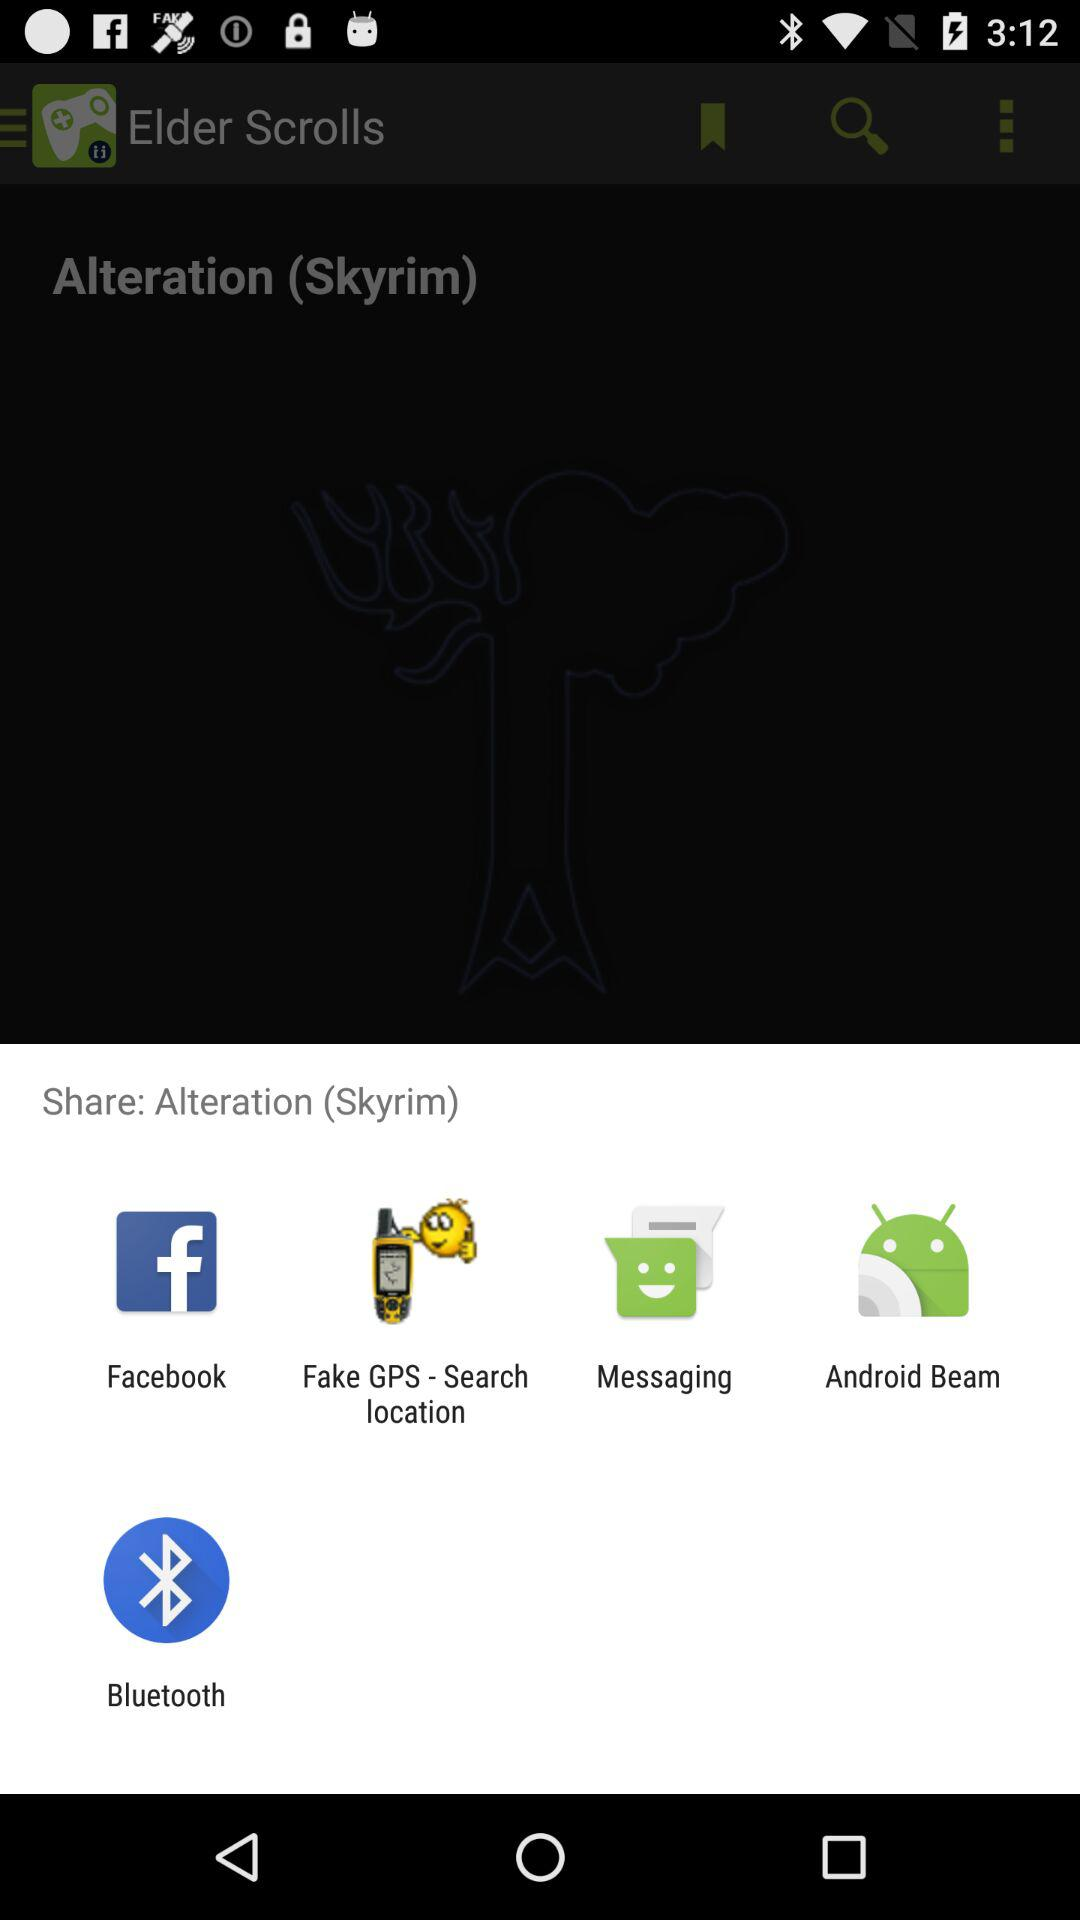Who is this application powered by?
When the provided information is insufficient, respond with <no answer>. <no answer> 